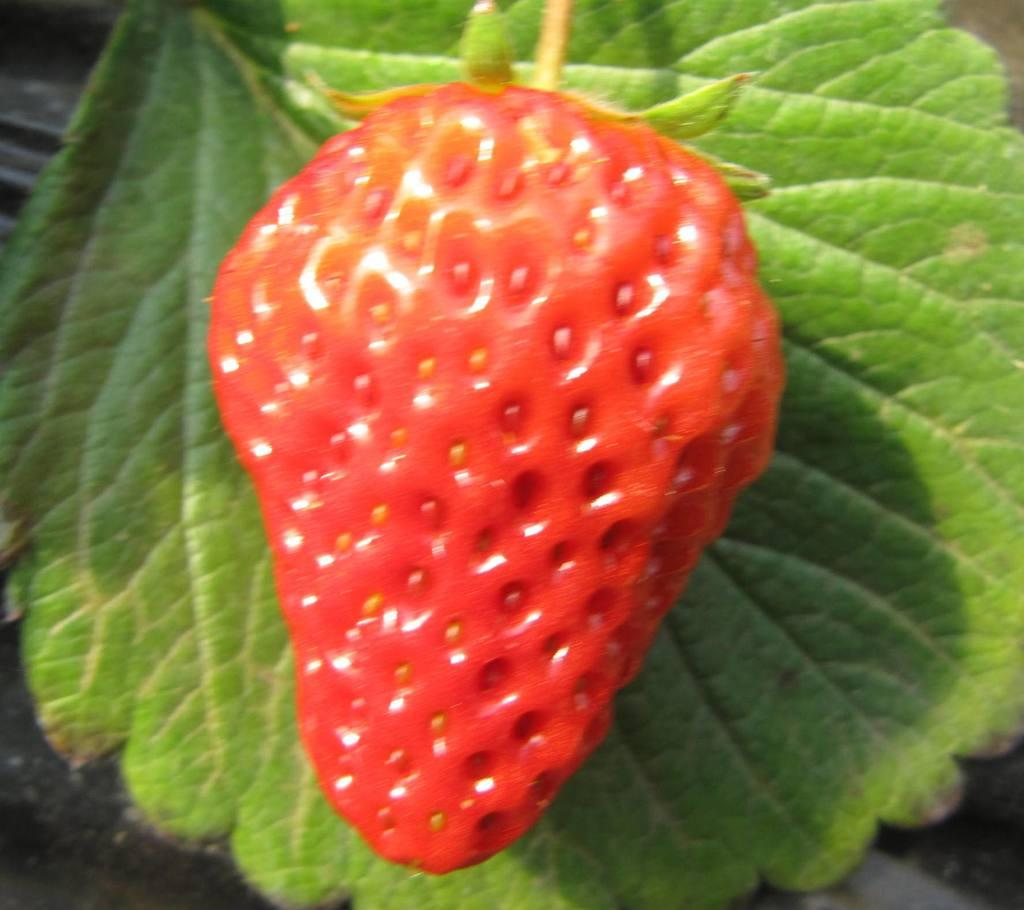What type of fruit is visible in the image? There is a strawberry in the image. What can be seen behind the strawberry? There is a leaf behind the strawberry in the image. What level of hope does the worm in the image express? There is no worm present in the image, so it is not possible to determine its level of hope. 